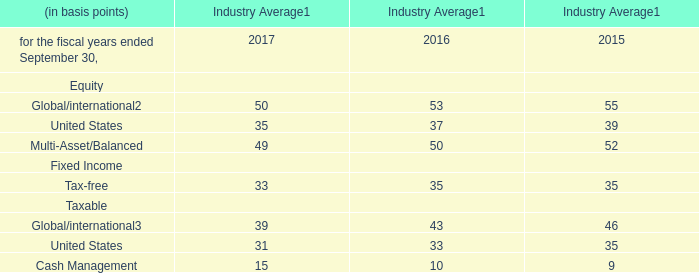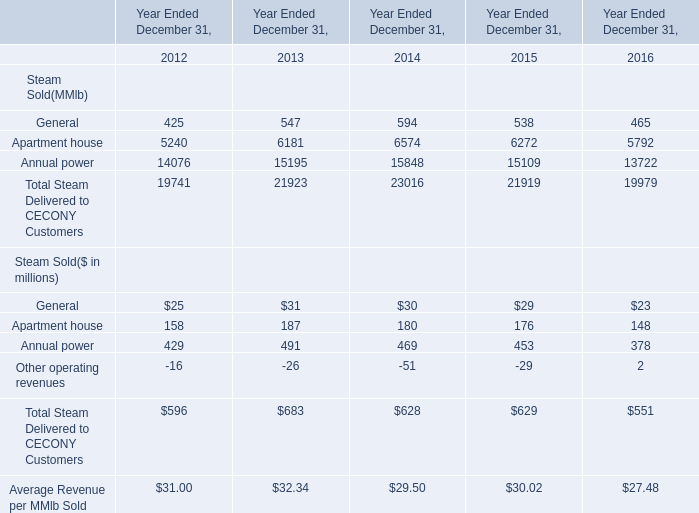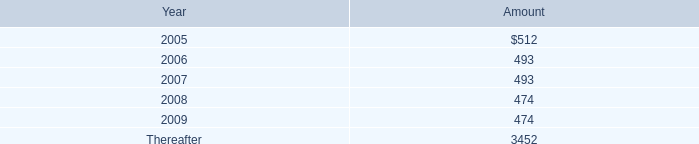In the year/section with the most Apartment house, what is the growth rate of Annual power? 
Computations: ((491 - 429) / 429)
Answer: 0.14452. 